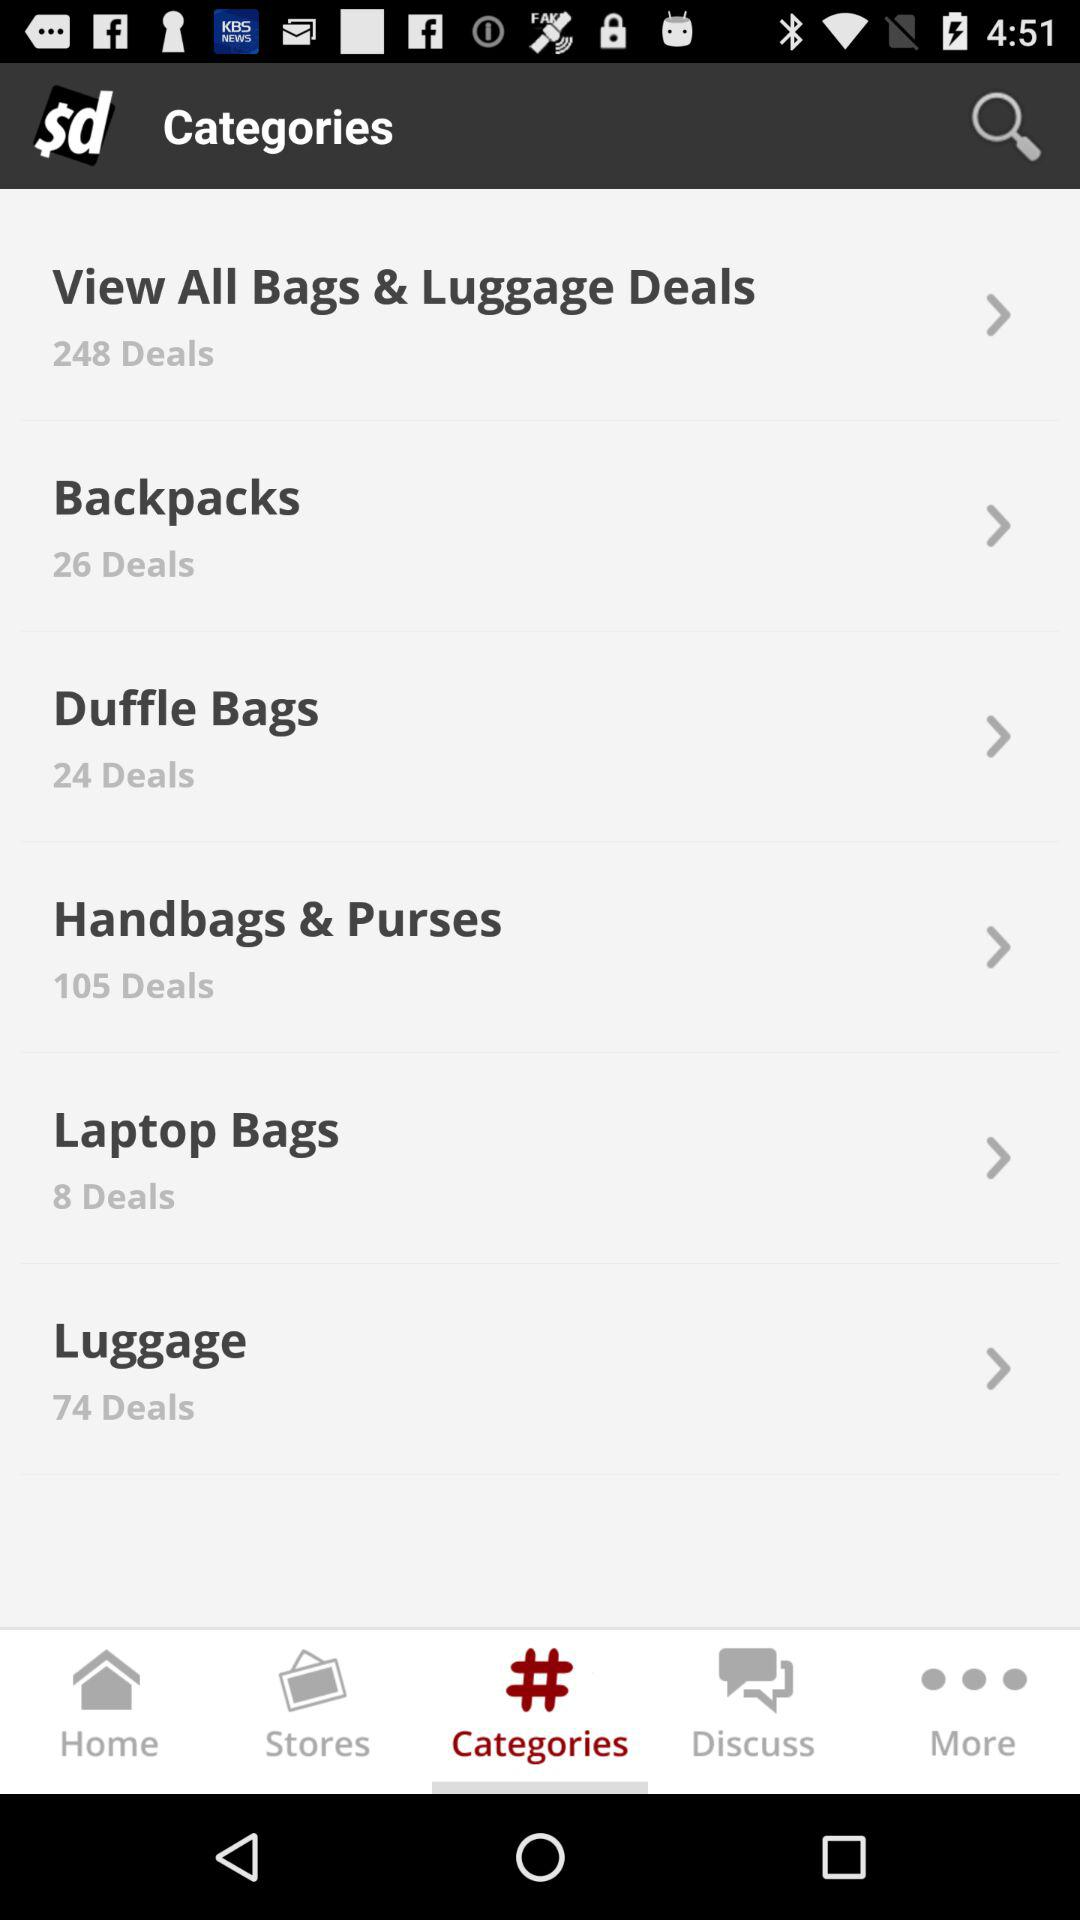Which tab is selected? The selected tab is categories. 